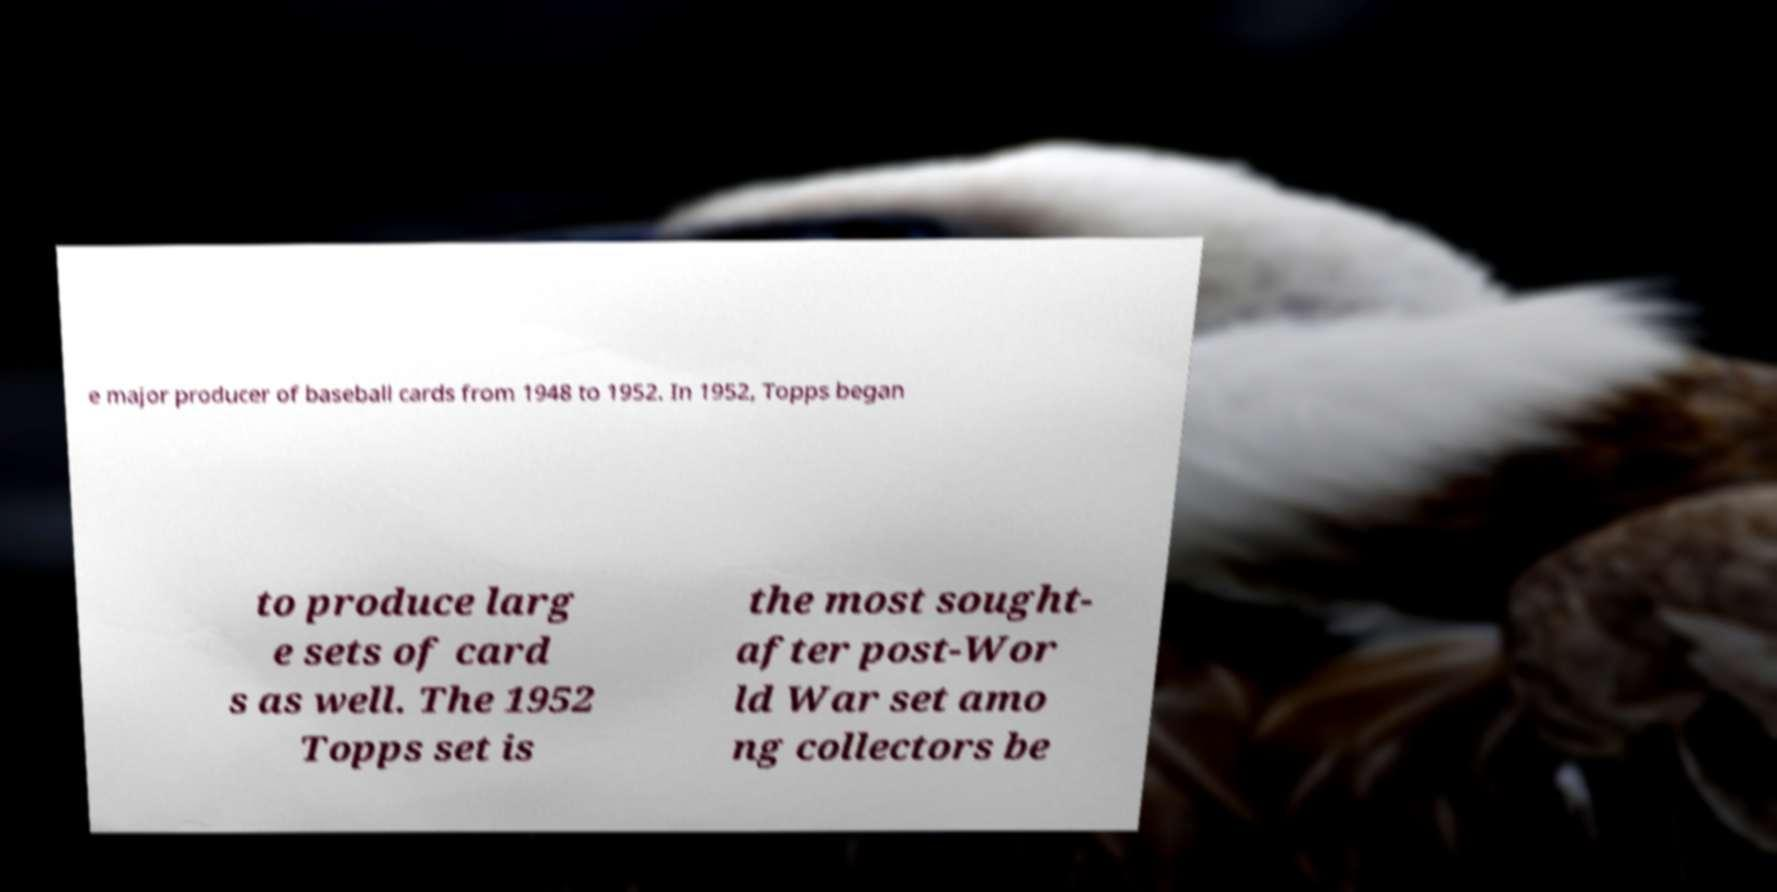Could you assist in decoding the text presented in this image and type it out clearly? e major producer of baseball cards from 1948 to 1952. In 1952, Topps began to produce larg e sets of card s as well. The 1952 Topps set is the most sought- after post-Wor ld War set amo ng collectors be 